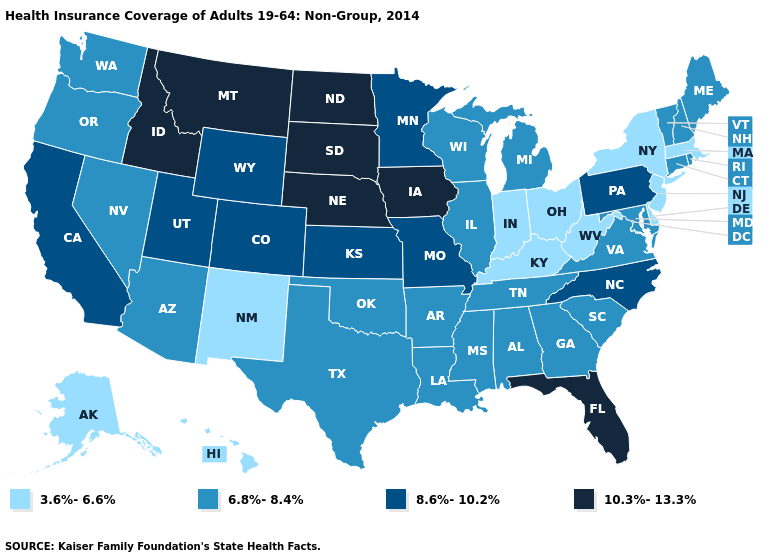Name the states that have a value in the range 8.6%-10.2%?
Short answer required. California, Colorado, Kansas, Minnesota, Missouri, North Carolina, Pennsylvania, Utah, Wyoming. Does Kentucky have the highest value in the South?
Quick response, please. No. Does New Jersey have a higher value than Virginia?
Short answer required. No. Does New Mexico have the lowest value in the West?
Answer briefly. Yes. Name the states that have a value in the range 6.8%-8.4%?
Keep it brief. Alabama, Arizona, Arkansas, Connecticut, Georgia, Illinois, Louisiana, Maine, Maryland, Michigan, Mississippi, Nevada, New Hampshire, Oklahoma, Oregon, Rhode Island, South Carolina, Tennessee, Texas, Vermont, Virginia, Washington, Wisconsin. What is the highest value in the USA?
Short answer required. 10.3%-13.3%. Does Vermont have the highest value in the Northeast?
Short answer required. No. Name the states that have a value in the range 8.6%-10.2%?
Keep it brief. California, Colorado, Kansas, Minnesota, Missouri, North Carolina, Pennsylvania, Utah, Wyoming. Which states have the lowest value in the West?
Quick response, please. Alaska, Hawaii, New Mexico. Is the legend a continuous bar?
Short answer required. No. What is the value of Minnesota?
Keep it brief. 8.6%-10.2%. What is the value of Kansas?
Give a very brief answer. 8.6%-10.2%. Does Nevada have the same value as Connecticut?
Concise answer only. Yes. Does the first symbol in the legend represent the smallest category?
Give a very brief answer. Yes. 